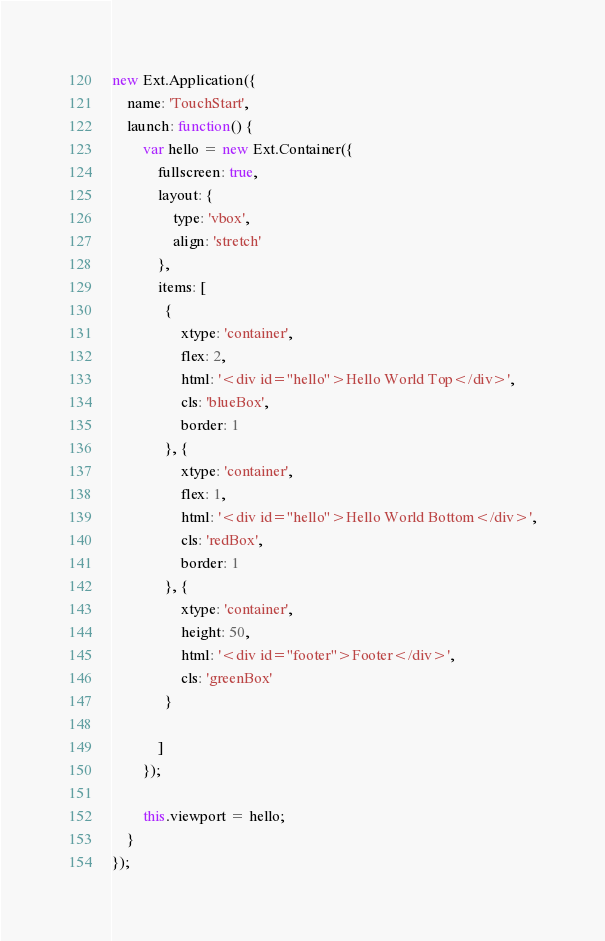<code> <loc_0><loc_0><loc_500><loc_500><_JavaScript_>new Ext.Application({
    name: 'TouchStart',
    launch: function() {
        var hello = new Ext.Container({
            fullscreen: true,
            layout: {
                type: 'vbox',
                align: 'stretch'
            },
            items: [
              {
                  xtype: 'container',
                  flex: 2,
                  html: '<div id="hello">Hello World Top</div>',
                  cls: 'blueBox',
                  border: 1
              }, {
                  xtype: 'container',
                  flex: 1,
                  html: '<div id="hello">Hello World Bottom</div>',
                  cls: 'redBox',
                  border: 1
              }, {
                  xtype: 'container',
                  height: 50,
                  html: '<div id="footer">Footer</div>',
                  cls: 'greenBox'
              }

            ]
        });

        this.viewport = hello;
    }
});
</code> 